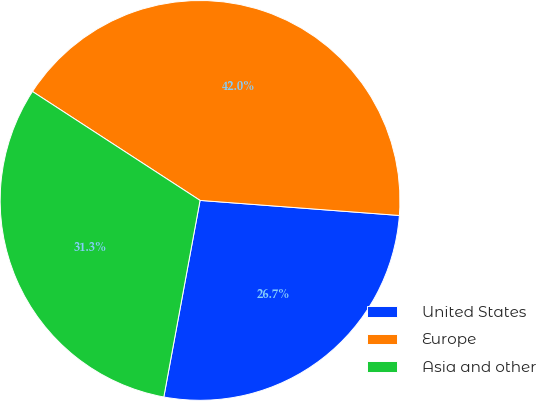Convert chart. <chart><loc_0><loc_0><loc_500><loc_500><pie_chart><fcel>United States<fcel>Europe<fcel>Asia and other<nl><fcel>26.7%<fcel>42.03%<fcel>31.27%<nl></chart> 